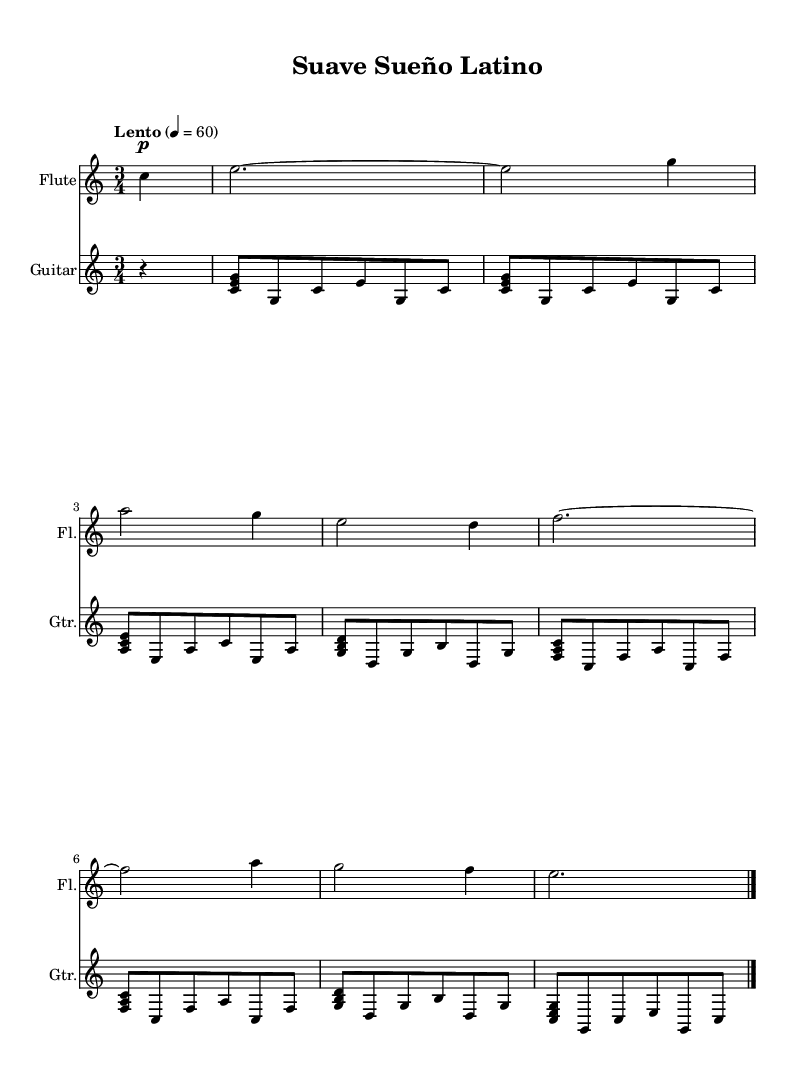What is the key signature of this music? The key signature for this piece is C major, which is indicated by the absence of any sharps or flats at the beginning of the staff.
Answer: C major What is the time signature of this music? The time signature is 3/4, shown at the beginning of the score, defining it as a waltz-style music with three beats per measure.
Answer: 3/4 What is the tempo marking of this music? The tempo marking is "Lento," which indicates a slow速度. This is followed by the BPM marking of 60, specifying the speed at which the music should be played.
Answer: Lento How many measures are in the flute part? The flute part contains a total of 8 measures, which can be counted by observing the bar lines dividing the music into equal sections.
Answer: 8 Which instruments are featured in this piece? The piece features two instruments, the flute and the guitar, both indicated by their respective staff labels at the beginning of each staff.
Answer: Flute, Guitar What type of musical piece is this? This musical piece is categorized as a Latin instrumental melody, as denoted by the title "Suave Sueño Latino," which translates to "Gentle Latin Sleep."
Answer: Latin instrumental What is the last note played by the flute? The last note played by the flute is a whole note E, which is indicated by the notation in the final measure before the closing bar line.
Answer: E 